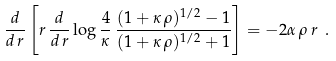<formula> <loc_0><loc_0><loc_500><loc_500>\frac { d } { d \, r } \left [ r \, \frac { d } { d \, r } \log \frac { 4 } { \kappa } \, \frac { ( 1 + \kappa \, \rho ) ^ { 1 / 2 } - 1 } { ( 1 + \kappa \, \rho ) ^ { 1 / 2 } + 1 } \right ] = - 2 \alpha \, \rho \, r \ .</formula> 